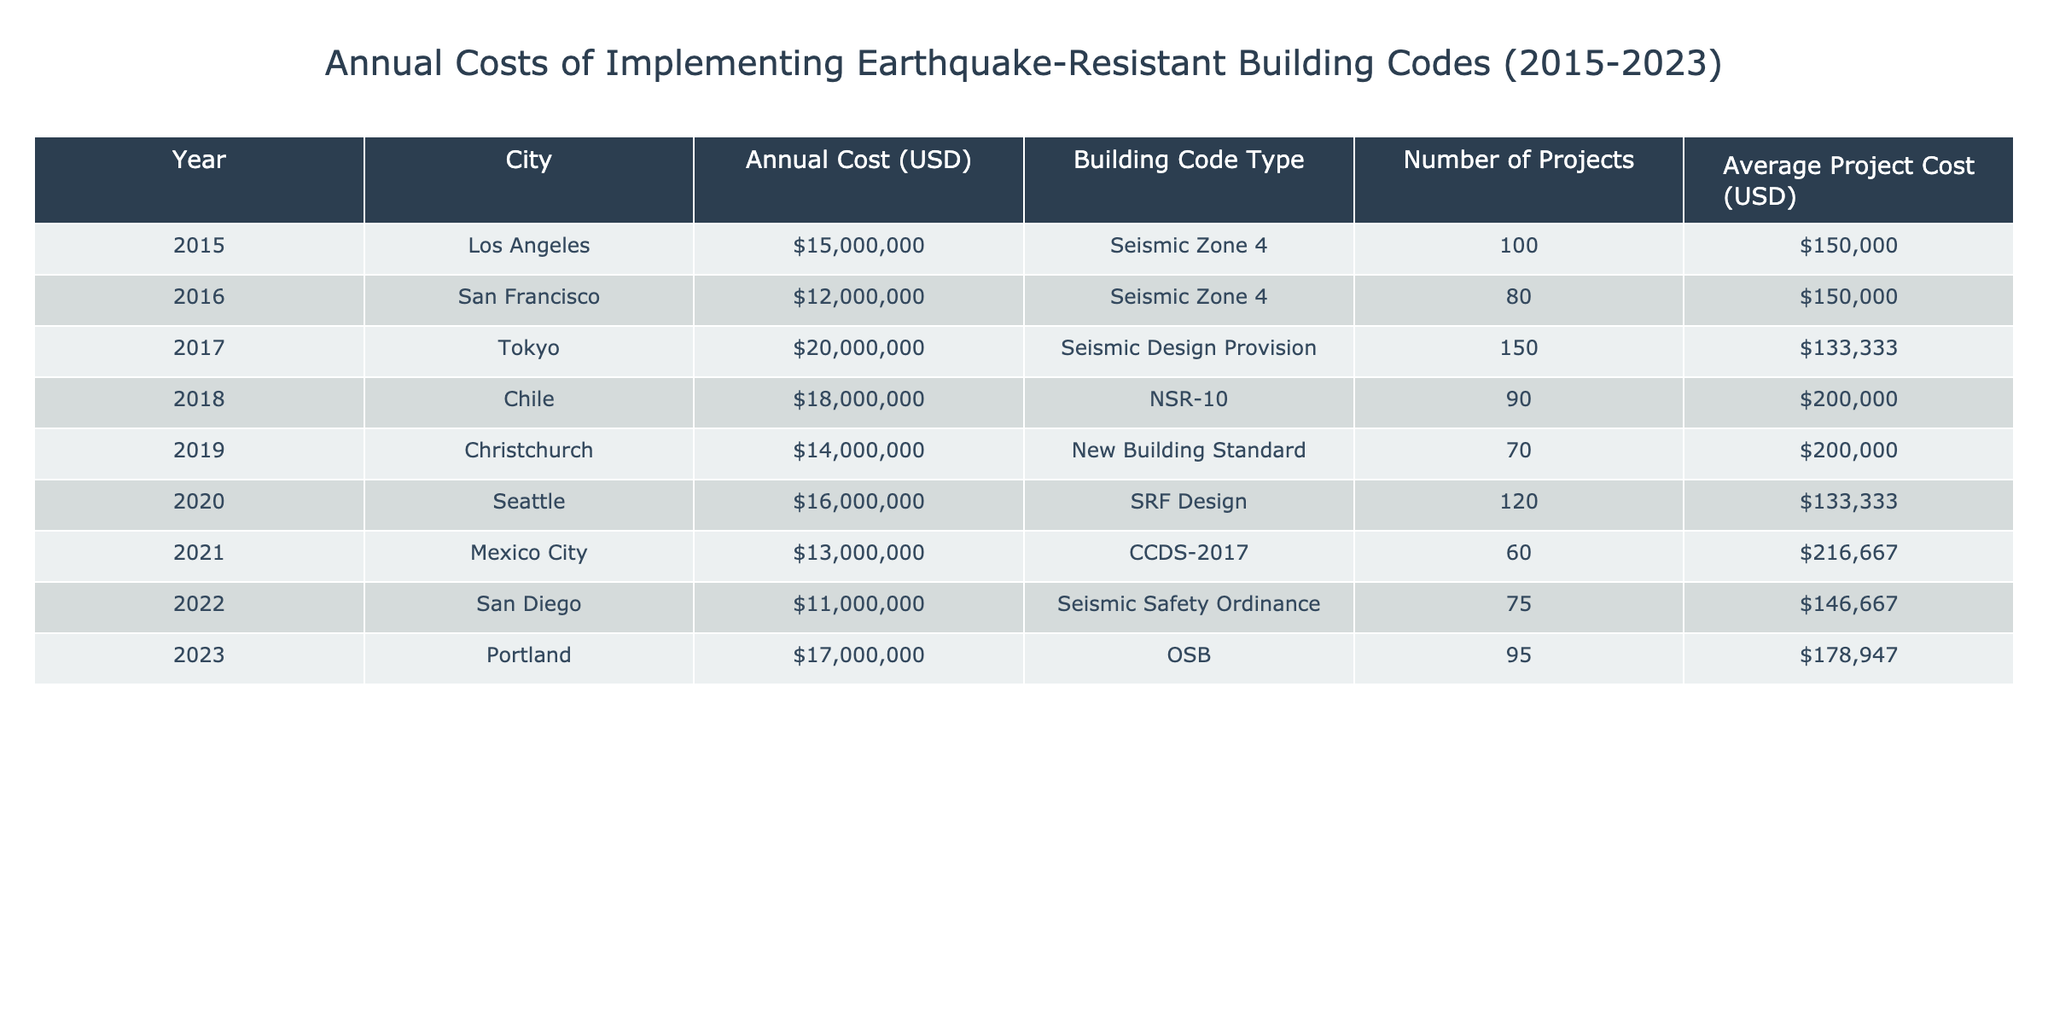What was the highest annual cost recorded for implementing earthquake-resistant building codes? By looking at the 'Annual Cost (USD)' column, we can see that the value for Tokyo in 2017 is the highest at 20,000,000.
Answer: 20,000,000 Which city had the lowest average project cost, and what was that cost? By checking the 'Average Project Cost (USD)' column, we find that Mexico City in 2021 had the lowest average project cost of 216,667.
Answer: 216,667 How many projects were undertaken in San Francisco in 2016? The table directly provides the value for San Francisco in 2016, which is 80 projects.
Answer: 80 What is the total annual cost for all cities in 2022 and 2023 combined? To find this, we add the annual costs for San Diego (11,000,000) and Portland (17,000,000), resulting in a total cost of 28,000,000.
Answer: 28,000,000 Did Christchuch incur more than 15,000,000 USD in 2019 for implementing earthquake-resistant building codes? The annual cost for Christchurch in 2019 is 14,000,000, which is less than 15,000,000, so the answer is no.
Answer: No What was the average annual cost across all cities from 2015 to 2023? Calculating the average involves summing the annual costs for all cities (15000000 + 12000000 + 20000000 + 18000000 + 14000000 + 16000000 + 13000000 + 11000000 + 17000000) which totals 1,260,000,000, and dividing that by the number of entries (9). The average is approximately 140,000,000 / 9 = 14000000.
Answer: 14000000 Did any city spend over 18,000,000 USD in any single year from 2015 to 2023? By scanning through the annual costs, we find that Tokyo in 2017 and Chile in 2018 did spend over 18,000,000, so the answer is yes.
Answer: Yes What is the difference in annual costs between the highest and lowest recorded in this data? The highest annual cost is 20,000,000 (Tokyo 2017), and the lowest is 11,000,000 (San Diego 2022). The difference is calculated as 20,000,000 - 11,000,000 = 9,000,000.
Answer: 9,000,000 